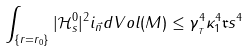Convert formula to latex. <formula><loc_0><loc_0><loc_500><loc_500>\int _ { \{ r = r _ { 0 } \} } | \mathcal { H } _ { s } ^ { 0 } | ^ { 2 } i _ { \vec { n } } d V o l ( M ) \leq \gamma _ { _ { T } } ^ { 4 } \kappa _ { 1 } ^ { 4 } \mathfrak { r } s ^ { 4 }</formula> 